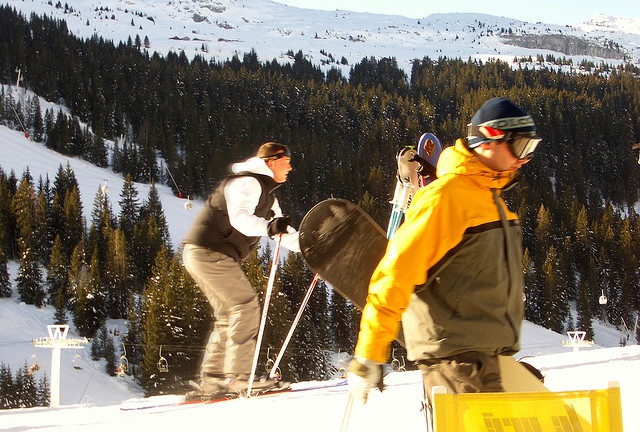Describe the objects in this image and their specific colors. I can see people in lightblue, olive, orange, maroon, and khaki tones, people in lightblue, ivory, tan, and black tones, snowboard in lightblue, maroon, black, and gray tones, and skis in lightblue, white, salmon, and tan tones in this image. 